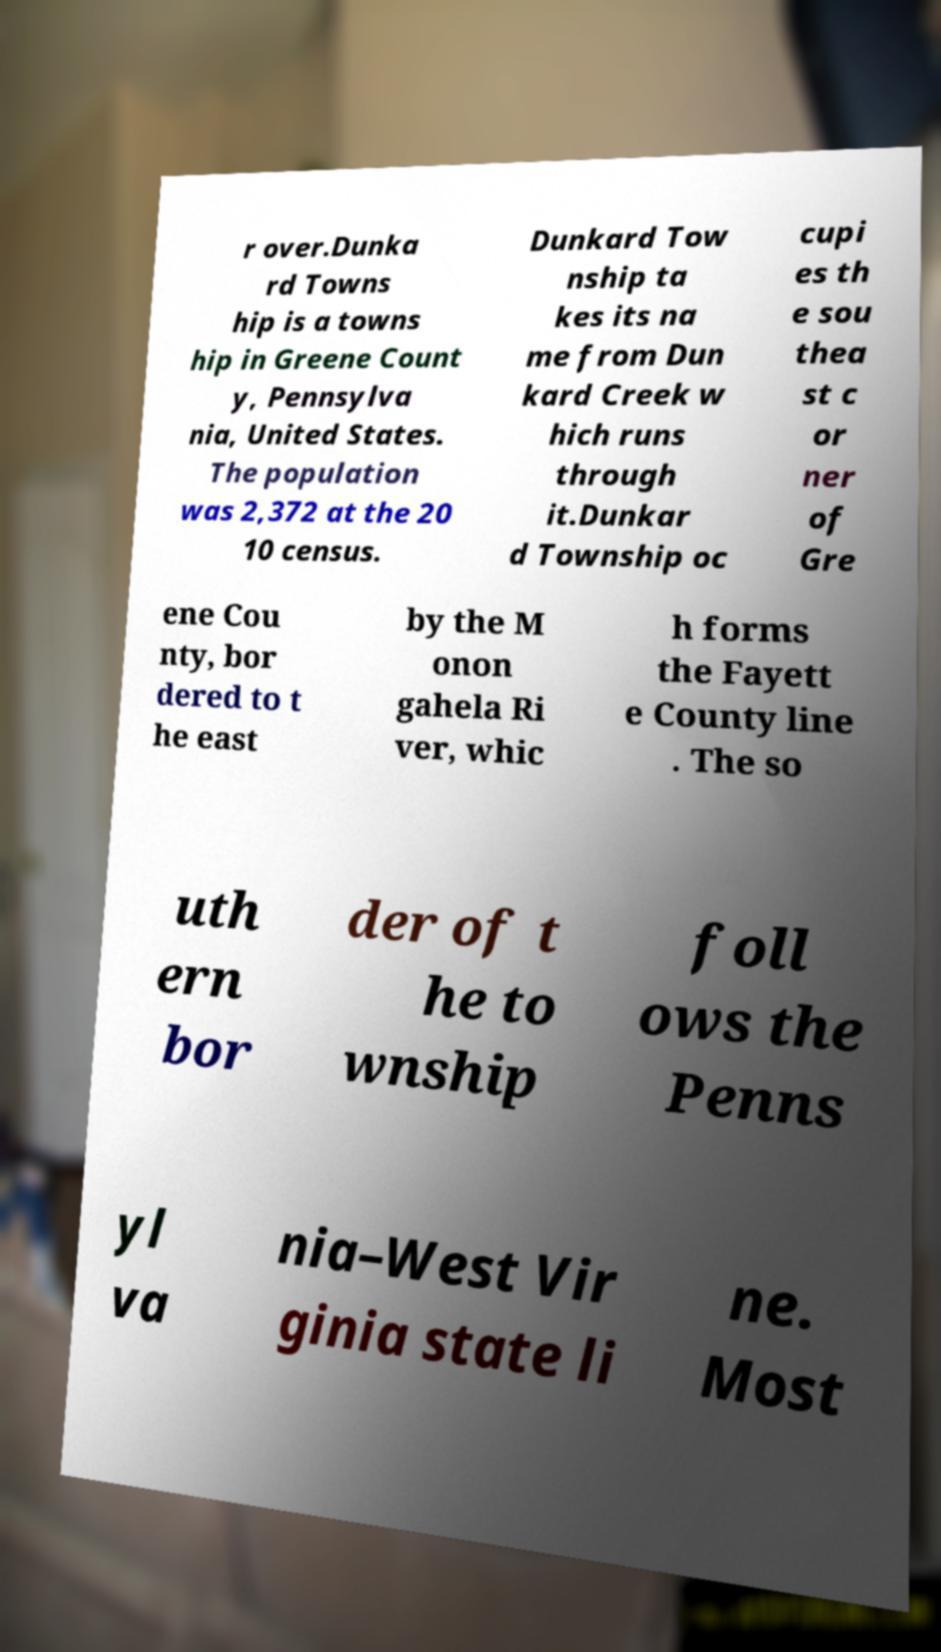Please read and relay the text visible in this image. What does it say? r over.Dunka rd Towns hip is a towns hip in Greene Count y, Pennsylva nia, United States. The population was 2,372 at the 20 10 census. Dunkard Tow nship ta kes its na me from Dun kard Creek w hich runs through it.Dunkar d Township oc cupi es th e sou thea st c or ner of Gre ene Cou nty, bor dered to t he east by the M onon gahela Ri ver, whic h forms the Fayett e County line . The so uth ern bor der of t he to wnship foll ows the Penns yl va nia–West Vir ginia state li ne. Most 